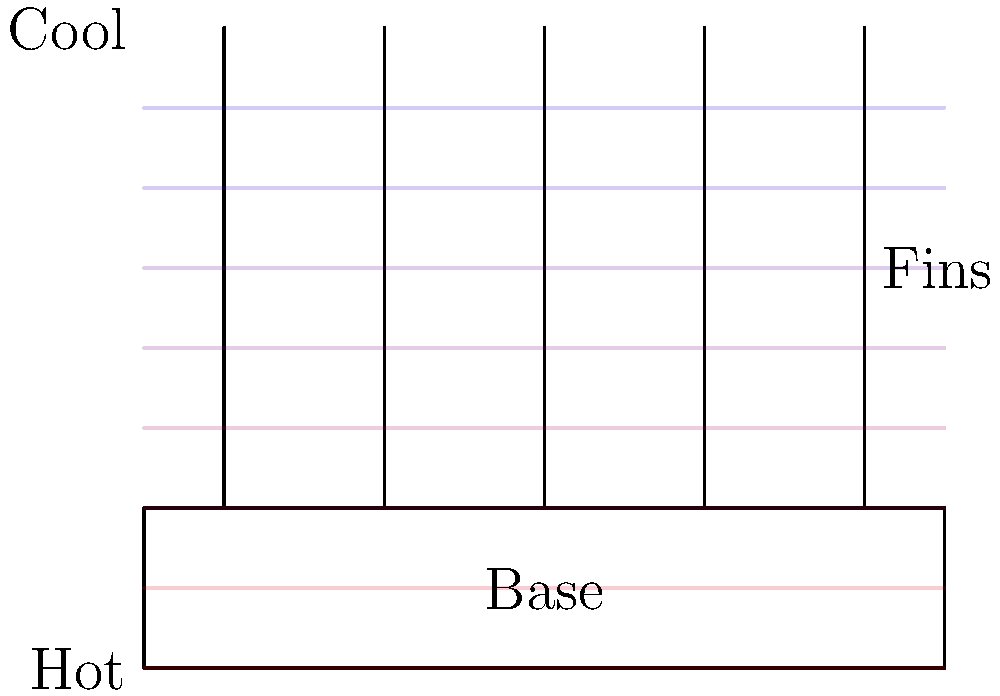In a heat sink with multiple fins, as shown in the diagram, how does the temperature typically change from the base to the tips of the fins? To understand the temperature distribution in a heat sink with multiple fins, let's consider the following steps:

1. Heat source: The base of the heat sink is usually in contact with a heat source (e.g., a computer processor).

2. Heat conduction: Heat is conducted from the base through the fins.

3. Temperature gradient: As we move away from the heat source, the temperature decreases.

4. Fin efficiency: The fins increase the surface area for heat dissipation.

5. Heat dissipation: As we move towards the tips of the fins, more heat is dissipated to the surrounding air.

6. Temperature profile: The temperature is highest at the base and gradually decreases towards the fin tips.

7. Coolest point: The tips of the fins are typically the coolest part of the heat sink.

This temperature distribution allows the heat sink to efficiently transfer heat from the source to the surrounding environment, with the fins providing additional surface area for heat dissipation.
Answer: Temperature decreases from base to fin tips 